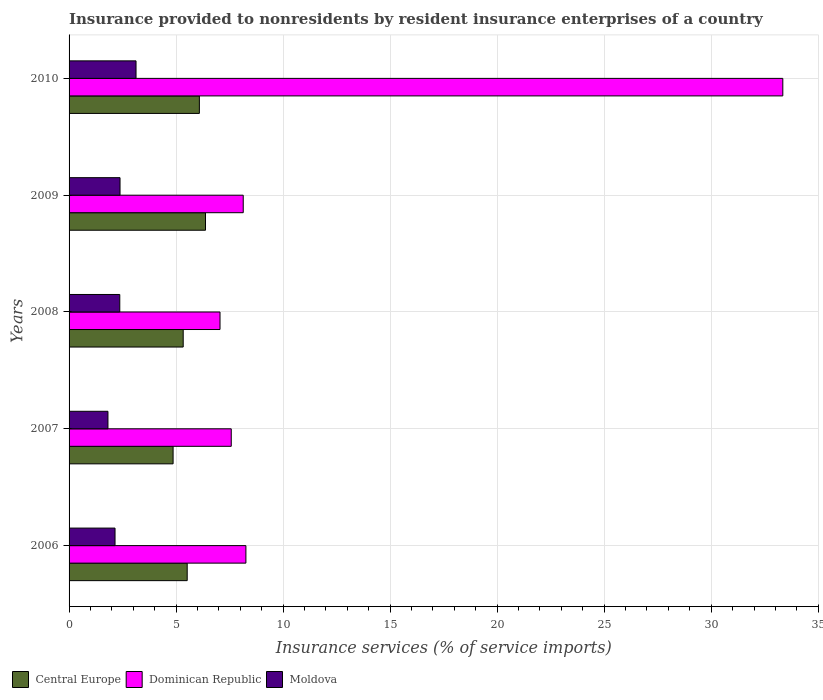Are the number of bars per tick equal to the number of legend labels?
Your response must be concise. Yes. In how many cases, is the number of bars for a given year not equal to the number of legend labels?
Give a very brief answer. 0. What is the insurance provided to nonresidents in Dominican Republic in 2006?
Your answer should be very brief. 8.26. Across all years, what is the maximum insurance provided to nonresidents in Dominican Republic?
Give a very brief answer. 33.35. Across all years, what is the minimum insurance provided to nonresidents in Moldova?
Ensure brevity in your answer.  1.82. In which year was the insurance provided to nonresidents in Dominican Republic maximum?
Ensure brevity in your answer.  2010. In which year was the insurance provided to nonresidents in Moldova minimum?
Your answer should be compact. 2007. What is the total insurance provided to nonresidents in Dominican Republic in the graph?
Make the answer very short. 64.37. What is the difference between the insurance provided to nonresidents in Central Europe in 2006 and that in 2010?
Offer a terse response. -0.57. What is the difference between the insurance provided to nonresidents in Moldova in 2008 and the insurance provided to nonresidents in Central Europe in 2007?
Your answer should be very brief. -2.49. What is the average insurance provided to nonresidents in Dominican Republic per year?
Your answer should be compact. 12.87. In the year 2007, what is the difference between the insurance provided to nonresidents in Dominican Republic and insurance provided to nonresidents in Moldova?
Make the answer very short. 5.76. In how many years, is the insurance provided to nonresidents in Dominican Republic greater than 18 %?
Make the answer very short. 1. What is the ratio of the insurance provided to nonresidents in Central Europe in 2007 to that in 2008?
Give a very brief answer. 0.91. What is the difference between the highest and the second highest insurance provided to nonresidents in Central Europe?
Keep it short and to the point. 0.29. What is the difference between the highest and the lowest insurance provided to nonresidents in Central Europe?
Your answer should be very brief. 1.51. In how many years, is the insurance provided to nonresidents in Moldova greater than the average insurance provided to nonresidents in Moldova taken over all years?
Give a very brief answer. 3. What does the 3rd bar from the top in 2007 represents?
Your response must be concise. Central Europe. What does the 1st bar from the bottom in 2007 represents?
Your response must be concise. Central Europe. How many bars are there?
Provide a succinct answer. 15. How many years are there in the graph?
Keep it short and to the point. 5. What is the difference between two consecutive major ticks on the X-axis?
Give a very brief answer. 5. Are the values on the major ticks of X-axis written in scientific E-notation?
Provide a short and direct response. No. Does the graph contain any zero values?
Offer a very short reply. No. Where does the legend appear in the graph?
Provide a short and direct response. Bottom left. What is the title of the graph?
Provide a short and direct response. Insurance provided to nonresidents by resident insurance enterprises of a country. Does "Curacao" appear as one of the legend labels in the graph?
Your answer should be compact. No. What is the label or title of the X-axis?
Your answer should be compact. Insurance services (% of service imports). What is the Insurance services (% of service imports) in Central Europe in 2006?
Make the answer very short. 5.52. What is the Insurance services (% of service imports) of Dominican Republic in 2006?
Offer a terse response. 8.26. What is the Insurance services (% of service imports) of Moldova in 2006?
Your response must be concise. 2.15. What is the Insurance services (% of service imports) in Central Europe in 2007?
Offer a terse response. 4.86. What is the Insurance services (% of service imports) of Dominican Republic in 2007?
Provide a short and direct response. 7.58. What is the Insurance services (% of service imports) in Moldova in 2007?
Your response must be concise. 1.82. What is the Insurance services (% of service imports) in Central Europe in 2008?
Make the answer very short. 5.33. What is the Insurance services (% of service imports) in Dominican Republic in 2008?
Give a very brief answer. 7.05. What is the Insurance services (% of service imports) in Moldova in 2008?
Make the answer very short. 2.37. What is the Insurance services (% of service imports) in Central Europe in 2009?
Your response must be concise. 6.37. What is the Insurance services (% of service imports) in Dominican Republic in 2009?
Ensure brevity in your answer.  8.14. What is the Insurance services (% of service imports) of Moldova in 2009?
Give a very brief answer. 2.38. What is the Insurance services (% of service imports) of Central Europe in 2010?
Offer a very short reply. 6.09. What is the Insurance services (% of service imports) in Dominican Republic in 2010?
Your answer should be compact. 33.35. What is the Insurance services (% of service imports) in Moldova in 2010?
Provide a short and direct response. 3.13. Across all years, what is the maximum Insurance services (% of service imports) in Central Europe?
Provide a short and direct response. 6.37. Across all years, what is the maximum Insurance services (% of service imports) of Dominican Republic?
Ensure brevity in your answer.  33.35. Across all years, what is the maximum Insurance services (% of service imports) of Moldova?
Offer a very short reply. 3.13. Across all years, what is the minimum Insurance services (% of service imports) of Central Europe?
Provide a short and direct response. 4.86. Across all years, what is the minimum Insurance services (% of service imports) in Dominican Republic?
Your response must be concise. 7.05. Across all years, what is the minimum Insurance services (% of service imports) in Moldova?
Offer a terse response. 1.82. What is the total Insurance services (% of service imports) of Central Europe in the graph?
Ensure brevity in your answer.  28.17. What is the total Insurance services (% of service imports) in Dominican Republic in the graph?
Ensure brevity in your answer.  64.37. What is the total Insurance services (% of service imports) of Moldova in the graph?
Your response must be concise. 11.84. What is the difference between the Insurance services (% of service imports) of Central Europe in 2006 and that in 2007?
Make the answer very short. 0.66. What is the difference between the Insurance services (% of service imports) in Dominican Republic in 2006 and that in 2007?
Ensure brevity in your answer.  0.68. What is the difference between the Insurance services (% of service imports) in Moldova in 2006 and that in 2007?
Offer a very short reply. 0.33. What is the difference between the Insurance services (% of service imports) in Central Europe in 2006 and that in 2008?
Provide a short and direct response. 0.19. What is the difference between the Insurance services (% of service imports) in Dominican Republic in 2006 and that in 2008?
Ensure brevity in your answer.  1.21. What is the difference between the Insurance services (% of service imports) of Moldova in 2006 and that in 2008?
Your response must be concise. -0.22. What is the difference between the Insurance services (% of service imports) of Central Europe in 2006 and that in 2009?
Your response must be concise. -0.85. What is the difference between the Insurance services (% of service imports) of Dominican Republic in 2006 and that in 2009?
Give a very brief answer. 0.12. What is the difference between the Insurance services (% of service imports) in Moldova in 2006 and that in 2009?
Offer a terse response. -0.23. What is the difference between the Insurance services (% of service imports) in Central Europe in 2006 and that in 2010?
Your answer should be very brief. -0.57. What is the difference between the Insurance services (% of service imports) of Dominican Republic in 2006 and that in 2010?
Make the answer very short. -25.08. What is the difference between the Insurance services (% of service imports) in Moldova in 2006 and that in 2010?
Ensure brevity in your answer.  -0.98. What is the difference between the Insurance services (% of service imports) of Central Europe in 2007 and that in 2008?
Your answer should be compact. -0.47. What is the difference between the Insurance services (% of service imports) in Dominican Republic in 2007 and that in 2008?
Provide a succinct answer. 0.52. What is the difference between the Insurance services (% of service imports) of Moldova in 2007 and that in 2008?
Your response must be concise. -0.55. What is the difference between the Insurance services (% of service imports) of Central Europe in 2007 and that in 2009?
Offer a very short reply. -1.51. What is the difference between the Insurance services (% of service imports) in Dominican Republic in 2007 and that in 2009?
Provide a succinct answer. -0.56. What is the difference between the Insurance services (% of service imports) of Moldova in 2007 and that in 2009?
Your answer should be compact. -0.56. What is the difference between the Insurance services (% of service imports) in Central Europe in 2007 and that in 2010?
Keep it short and to the point. -1.23. What is the difference between the Insurance services (% of service imports) of Dominican Republic in 2007 and that in 2010?
Your answer should be very brief. -25.77. What is the difference between the Insurance services (% of service imports) in Moldova in 2007 and that in 2010?
Ensure brevity in your answer.  -1.31. What is the difference between the Insurance services (% of service imports) in Central Europe in 2008 and that in 2009?
Provide a succinct answer. -1.04. What is the difference between the Insurance services (% of service imports) of Dominican Republic in 2008 and that in 2009?
Offer a very short reply. -1.08. What is the difference between the Insurance services (% of service imports) of Moldova in 2008 and that in 2009?
Your response must be concise. -0.01. What is the difference between the Insurance services (% of service imports) of Central Europe in 2008 and that in 2010?
Give a very brief answer. -0.76. What is the difference between the Insurance services (% of service imports) in Dominican Republic in 2008 and that in 2010?
Ensure brevity in your answer.  -26.29. What is the difference between the Insurance services (% of service imports) in Moldova in 2008 and that in 2010?
Your response must be concise. -0.76. What is the difference between the Insurance services (% of service imports) in Central Europe in 2009 and that in 2010?
Your answer should be very brief. 0.29. What is the difference between the Insurance services (% of service imports) in Dominican Republic in 2009 and that in 2010?
Keep it short and to the point. -25.21. What is the difference between the Insurance services (% of service imports) in Moldova in 2009 and that in 2010?
Give a very brief answer. -0.75. What is the difference between the Insurance services (% of service imports) of Central Europe in 2006 and the Insurance services (% of service imports) of Dominican Republic in 2007?
Your answer should be very brief. -2.06. What is the difference between the Insurance services (% of service imports) in Central Europe in 2006 and the Insurance services (% of service imports) in Moldova in 2007?
Your answer should be compact. 3.7. What is the difference between the Insurance services (% of service imports) in Dominican Republic in 2006 and the Insurance services (% of service imports) in Moldova in 2007?
Keep it short and to the point. 6.45. What is the difference between the Insurance services (% of service imports) of Central Europe in 2006 and the Insurance services (% of service imports) of Dominican Republic in 2008?
Your response must be concise. -1.53. What is the difference between the Insurance services (% of service imports) in Central Europe in 2006 and the Insurance services (% of service imports) in Moldova in 2008?
Provide a succinct answer. 3.15. What is the difference between the Insurance services (% of service imports) of Dominican Republic in 2006 and the Insurance services (% of service imports) of Moldova in 2008?
Your response must be concise. 5.89. What is the difference between the Insurance services (% of service imports) in Central Europe in 2006 and the Insurance services (% of service imports) in Dominican Republic in 2009?
Offer a terse response. -2.62. What is the difference between the Insurance services (% of service imports) of Central Europe in 2006 and the Insurance services (% of service imports) of Moldova in 2009?
Provide a succinct answer. 3.14. What is the difference between the Insurance services (% of service imports) of Dominican Republic in 2006 and the Insurance services (% of service imports) of Moldova in 2009?
Provide a succinct answer. 5.88. What is the difference between the Insurance services (% of service imports) in Central Europe in 2006 and the Insurance services (% of service imports) in Dominican Republic in 2010?
Your response must be concise. -27.83. What is the difference between the Insurance services (% of service imports) in Central Europe in 2006 and the Insurance services (% of service imports) in Moldova in 2010?
Give a very brief answer. 2.39. What is the difference between the Insurance services (% of service imports) in Dominican Republic in 2006 and the Insurance services (% of service imports) in Moldova in 2010?
Provide a succinct answer. 5.13. What is the difference between the Insurance services (% of service imports) of Central Europe in 2007 and the Insurance services (% of service imports) of Dominican Republic in 2008?
Give a very brief answer. -2.19. What is the difference between the Insurance services (% of service imports) of Central Europe in 2007 and the Insurance services (% of service imports) of Moldova in 2008?
Your answer should be compact. 2.49. What is the difference between the Insurance services (% of service imports) of Dominican Republic in 2007 and the Insurance services (% of service imports) of Moldova in 2008?
Provide a succinct answer. 5.21. What is the difference between the Insurance services (% of service imports) in Central Europe in 2007 and the Insurance services (% of service imports) in Dominican Republic in 2009?
Make the answer very short. -3.28. What is the difference between the Insurance services (% of service imports) in Central Europe in 2007 and the Insurance services (% of service imports) in Moldova in 2009?
Offer a very short reply. 2.48. What is the difference between the Insurance services (% of service imports) of Dominican Republic in 2007 and the Insurance services (% of service imports) of Moldova in 2009?
Offer a terse response. 5.2. What is the difference between the Insurance services (% of service imports) of Central Europe in 2007 and the Insurance services (% of service imports) of Dominican Republic in 2010?
Offer a very short reply. -28.49. What is the difference between the Insurance services (% of service imports) of Central Europe in 2007 and the Insurance services (% of service imports) of Moldova in 2010?
Provide a succinct answer. 1.73. What is the difference between the Insurance services (% of service imports) in Dominican Republic in 2007 and the Insurance services (% of service imports) in Moldova in 2010?
Give a very brief answer. 4.45. What is the difference between the Insurance services (% of service imports) in Central Europe in 2008 and the Insurance services (% of service imports) in Dominican Republic in 2009?
Give a very brief answer. -2.8. What is the difference between the Insurance services (% of service imports) in Central Europe in 2008 and the Insurance services (% of service imports) in Moldova in 2009?
Keep it short and to the point. 2.95. What is the difference between the Insurance services (% of service imports) of Dominican Republic in 2008 and the Insurance services (% of service imports) of Moldova in 2009?
Your answer should be compact. 4.67. What is the difference between the Insurance services (% of service imports) in Central Europe in 2008 and the Insurance services (% of service imports) in Dominican Republic in 2010?
Provide a succinct answer. -28.01. What is the difference between the Insurance services (% of service imports) in Central Europe in 2008 and the Insurance services (% of service imports) in Moldova in 2010?
Provide a succinct answer. 2.2. What is the difference between the Insurance services (% of service imports) in Dominican Republic in 2008 and the Insurance services (% of service imports) in Moldova in 2010?
Your response must be concise. 3.92. What is the difference between the Insurance services (% of service imports) of Central Europe in 2009 and the Insurance services (% of service imports) of Dominican Republic in 2010?
Your response must be concise. -26.97. What is the difference between the Insurance services (% of service imports) in Central Europe in 2009 and the Insurance services (% of service imports) in Moldova in 2010?
Offer a very short reply. 3.25. What is the difference between the Insurance services (% of service imports) in Dominican Republic in 2009 and the Insurance services (% of service imports) in Moldova in 2010?
Make the answer very short. 5.01. What is the average Insurance services (% of service imports) of Central Europe per year?
Your answer should be very brief. 5.63. What is the average Insurance services (% of service imports) in Dominican Republic per year?
Offer a terse response. 12.87. What is the average Insurance services (% of service imports) of Moldova per year?
Your answer should be very brief. 2.37. In the year 2006, what is the difference between the Insurance services (% of service imports) in Central Europe and Insurance services (% of service imports) in Dominican Republic?
Your answer should be very brief. -2.74. In the year 2006, what is the difference between the Insurance services (% of service imports) in Central Europe and Insurance services (% of service imports) in Moldova?
Offer a very short reply. 3.37. In the year 2006, what is the difference between the Insurance services (% of service imports) of Dominican Republic and Insurance services (% of service imports) of Moldova?
Make the answer very short. 6.11. In the year 2007, what is the difference between the Insurance services (% of service imports) in Central Europe and Insurance services (% of service imports) in Dominican Republic?
Your response must be concise. -2.72. In the year 2007, what is the difference between the Insurance services (% of service imports) in Central Europe and Insurance services (% of service imports) in Moldova?
Offer a very short reply. 3.04. In the year 2007, what is the difference between the Insurance services (% of service imports) in Dominican Republic and Insurance services (% of service imports) in Moldova?
Provide a short and direct response. 5.76. In the year 2008, what is the difference between the Insurance services (% of service imports) in Central Europe and Insurance services (% of service imports) in Dominican Republic?
Offer a very short reply. -1.72. In the year 2008, what is the difference between the Insurance services (% of service imports) of Central Europe and Insurance services (% of service imports) of Moldova?
Ensure brevity in your answer.  2.96. In the year 2008, what is the difference between the Insurance services (% of service imports) in Dominican Republic and Insurance services (% of service imports) in Moldova?
Your answer should be compact. 4.68. In the year 2009, what is the difference between the Insurance services (% of service imports) in Central Europe and Insurance services (% of service imports) in Dominican Republic?
Offer a very short reply. -1.76. In the year 2009, what is the difference between the Insurance services (% of service imports) of Central Europe and Insurance services (% of service imports) of Moldova?
Provide a succinct answer. 3.99. In the year 2009, what is the difference between the Insurance services (% of service imports) in Dominican Republic and Insurance services (% of service imports) in Moldova?
Your response must be concise. 5.76. In the year 2010, what is the difference between the Insurance services (% of service imports) in Central Europe and Insurance services (% of service imports) in Dominican Republic?
Offer a terse response. -27.26. In the year 2010, what is the difference between the Insurance services (% of service imports) in Central Europe and Insurance services (% of service imports) in Moldova?
Your answer should be compact. 2.96. In the year 2010, what is the difference between the Insurance services (% of service imports) in Dominican Republic and Insurance services (% of service imports) in Moldova?
Make the answer very short. 30.22. What is the ratio of the Insurance services (% of service imports) in Central Europe in 2006 to that in 2007?
Your response must be concise. 1.14. What is the ratio of the Insurance services (% of service imports) in Dominican Republic in 2006 to that in 2007?
Your answer should be compact. 1.09. What is the ratio of the Insurance services (% of service imports) in Moldova in 2006 to that in 2007?
Give a very brief answer. 1.18. What is the ratio of the Insurance services (% of service imports) in Central Europe in 2006 to that in 2008?
Make the answer very short. 1.04. What is the ratio of the Insurance services (% of service imports) in Dominican Republic in 2006 to that in 2008?
Keep it short and to the point. 1.17. What is the ratio of the Insurance services (% of service imports) of Moldova in 2006 to that in 2008?
Provide a short and direct response. 0.91. What is the ratio of the Insurance services (% of service imports) in Central Europe in 2006 to that in 2009?
Your answer should be very brief. 0.87. What is the ratio of the Insurance services (% of service imports) in Dominican Republic in 2006 to that in 2009?
Keep it short and to the point. 1.02. What is the ratio of the Insurance services (% of service imports) in Moldova in 2006 to that in 2009?
Make the answer very short. 0.9. What is the ratio of the Insurance services (% of service imports) in Central Europe in 2006 to that in 2010?
Your answer should be very brief. 0.91. What is the ratio of the Insurance services (% of service imports) in Dominican Republic in 2006 to that in 2010?
Provide a succinct answer. 0.25. What is the ratio of the Insurance services (% of service imports) of Moldova in 2006 to that in 2010?
Provide a succinct answer. 0.69. What is the ratio of the Insurance services (% of service imports) of Central Europe in 2007 to that in 2008?
Make the answer very short. 0.91. What is the ratio of the Insurance services (% of service imports) of Dominican Republic in 2007 to that in 2008?
Your response must be concise. 1.07. What is the ratio of the Insurance services (% of service imports) in Moldova in 2007 to that in 2008?
Ensure brevity in your answer.  0.77. What is the ratio of the Insurance services (% of service imports) of Central Europe in 2007 to that in 2009?
Keep it short and to the point. 0.76. What is the ratio of the Insurance services (% of service imports) of Dominican Republic in 2007 to that in 2009?
Your response must be concise. 0.93. What is the ratio of the Insurance services (% of service imports) of Moldova in 2007 to that in 2009?
Keep it short and to the point. 0.76. What is the ratio of the Insurance services (% of service imports) in Central Europe in 2007 to that in 2010?
Offer a terse response. 0.8. What is the ratio of the Insurance services (% of service imports) in Dominican Republic in 2007 to that in 2010?
Provide a succinct answer. 0.23. What is the ratio of the Insurance services (% of service imports) in Moldova in 2007 to that in 2010?
Provide a short and direct response. 0.58. What is the ratio of the Insurance services (% of service imports) in Central Europe in 2008 to that in 2009?
Ensure brevity in your answer.  0.84. What is the ratio of the Insurance services (% of service imports) of Dominican Republic in 2008 to that in 2009?
Your response must be concise. 0.87. What is the ratio of the Insurance services (% of service imports) in Moldova in 2008 to that in 2009?
Provide a succinct answer. 0.99. What is the ratio of the Insurance services (% of service imports) of Central Europe in 2008 to that in 2010?
Provide a short and direct response. 0.88. What is the ratio of the Insurance services (% of service imports) of Dominican Republic in 2008 to that in 2010?
Offer a very short reply. 0.21. What is the ratio of the Insurance services (% of service imports) in Moldova in 2008 to that in 2010?
Keep it short and to the point. 0.76. What is the ratio of the Insurance services (% of service imports) in Central Europe in 2009 to that in 2010?
Offer a very short reply. 1.05. What is the ratio of the Insurance services (% of service imports) of Dominican Republic in 2009 to that in 2010?
Your answer should be compact. 0.24. What is the ratio of the Insurance services (% of service imports) of Moldova in 2009 to that in 2010?
Provide a succinct answer. 0.76. What is the difference between the highest and the second highest Insurance services (% of service imports) of Central Europe?
Offer a very short reply. 0.29. What is the difference between the highest and the second highest Insurance services (% of service imports) of Dominican Republic?
Your response must be concise. 25.08. What is the difference between the highest and the second highest Insurance services (% of service imports) of Moldova?
Give a very brief answer. 0.75. What is the difference between the highest and the lowest Insurance services (% of service imports) of Central Europe?
Your answer should be compact. 1.51. What is the difference between the highest and the lowest Insurance services (% of service imports) in Dominican Republic?
Ensure brevity in your answer.  26.29. What is the difference between the highest and the lowest Insurance services (% of service imports) of Moldova?
Keep it short and to the point. 1.31. 